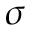<formula> <loc_0><loc_0><loc_500><loc_500>\sigma</formula> 